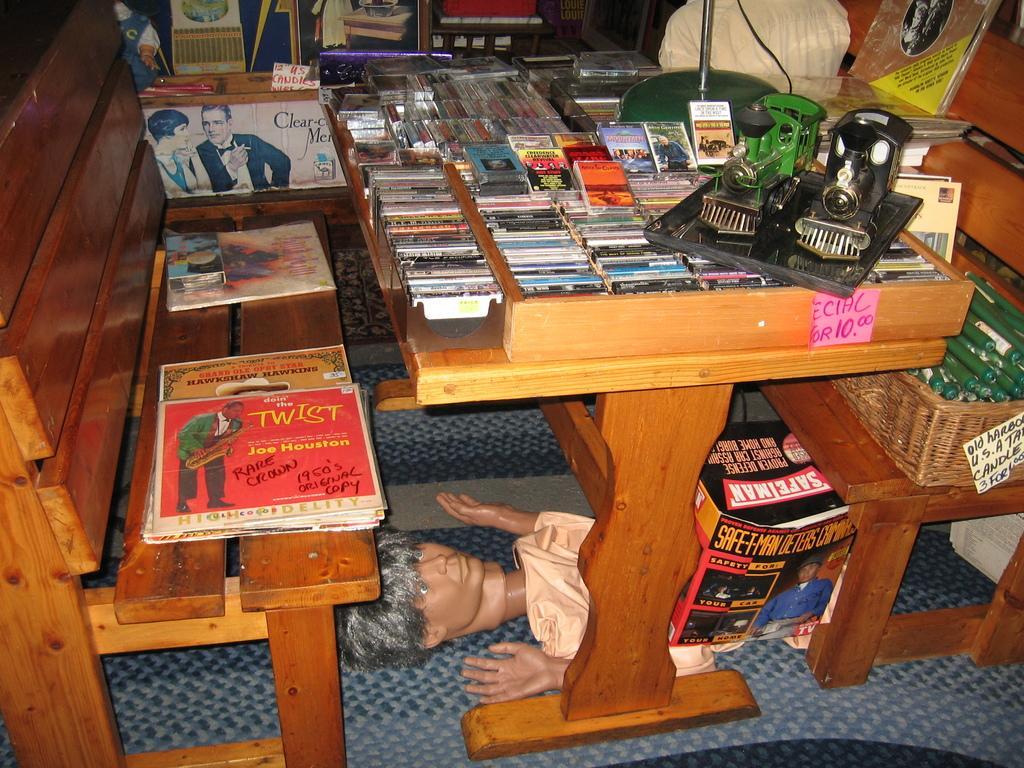Describe this image in one or two sentences. This is the picture of a table on which some things are placed. 